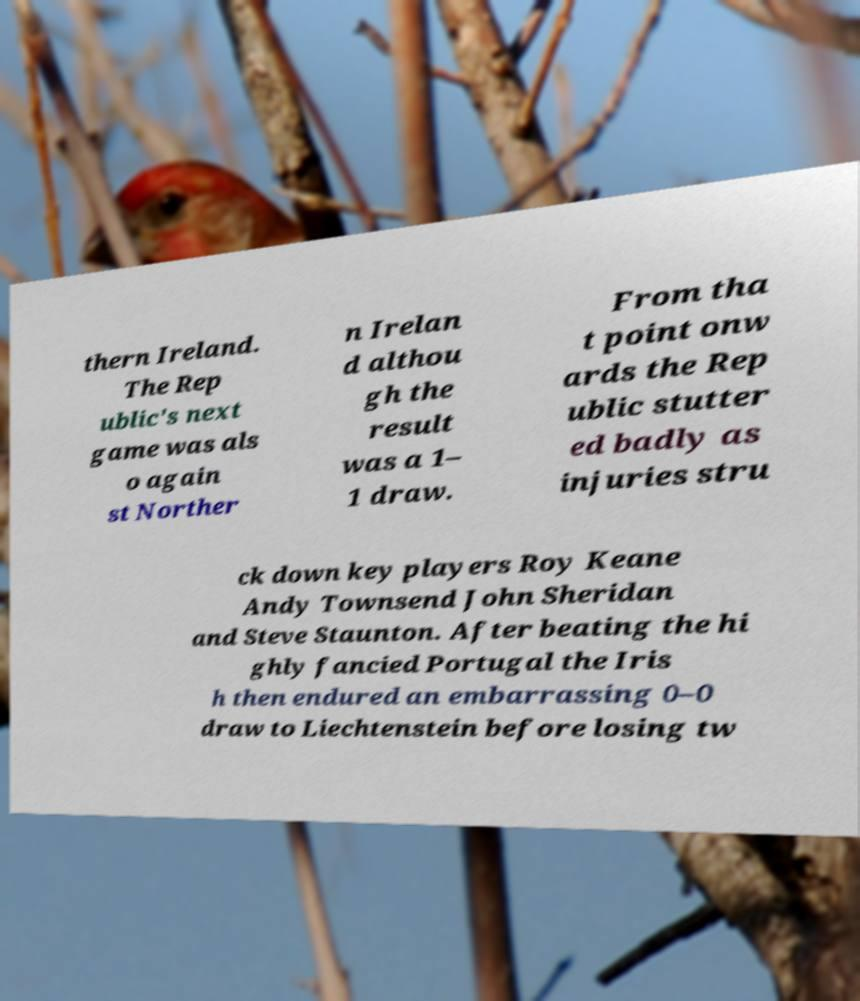Could you extract and type out the text from this image? thern Ireland. The Rep ublic's next game was als o again st Norther n Irelan d althou gh the result was a 1– 1 draw. From tha t point onw ards the Rep ublic stutter ed badly as injuries stru ck down key players Roy Keane Andy Townsend John Sheridan and Steve Staunton. After beating the hi ghly fancied Portugal the Iris h then endured an embarrassing 0–0 draw to Liechtenstein before losing tw 